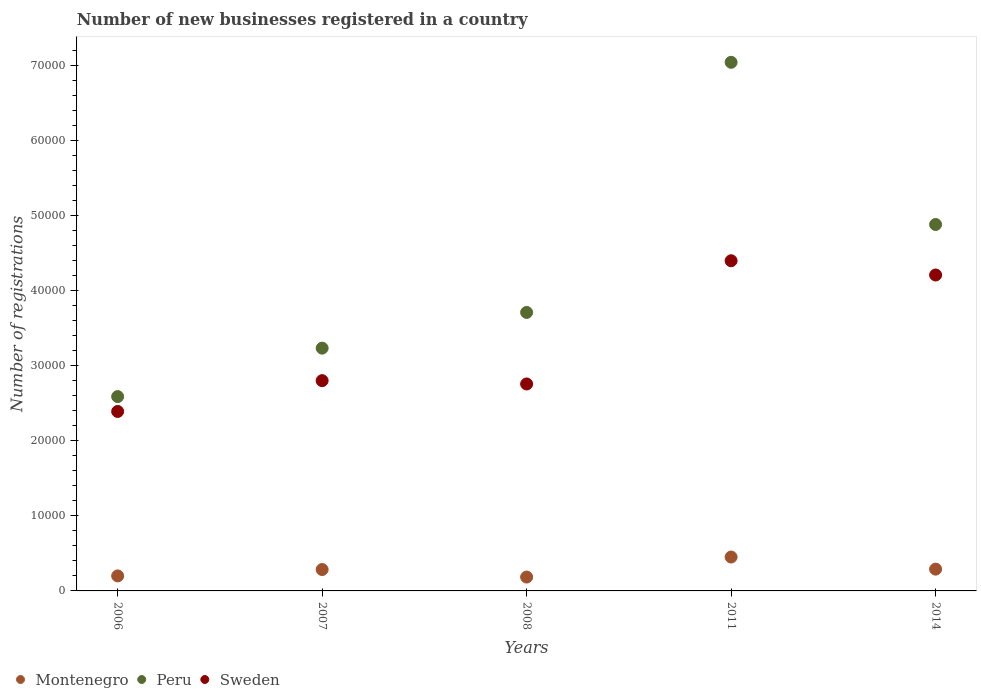What is the number of new businesses registered in Sweden in 2011?
Your response must be concise. 4.40e+04. Across all years, what is the maximum number of new businesses registered in Peru?
Offer a terse response. 7.04e+04. Across all years, what is the minimum number of new businesses registered in Peru?
Make the answer very short. 2.59e+04. In which year was the number of new businesses registered in Sweden maximum?
Keep it short and to the point. 2011. In which year was the number of new businesses registered in Peru minimum?
Your answer should be compact. 2006. What is the total number of new businesses registered in Sweden in the graph?
Your answer should be very brief. 1.65e+05. What is the difference between the number of new businesses registered in Montenegro in 2007 and that in 2011?
Offer a very short reply. -1665. What is the difference between the number of new businesses registered in Sweden in 2011 and the number of new businesses registered in Peru in 2007?
Your answer should be very brief. 1.16e+04. What is the average number of new businesses registered in Montenegro per year?
Keep it short and to the point. 2821.4. In the year 2007, what is the difference between the number of new businesses registered in Sweden and number of new businesses registered in Peru?
Your answer should be very brief. -4327. What is the ratio of the number of new businesses registered in Sweden in 2007 to that in 2014?
Keep it short and to the point. 0.67. Is the number of new businesses registered in Montenegro in 2008 less than that in 2011?
Give a very brief answer. Yes. Is the difference between the number of new businesses registered in Sweden in 2006 and 2011 greater than the difference between the number of new businesses registered in Peru in 2006 and 2011?
Provide a succinct answer. Yes. What is the difference between the highest and the second highest number of new businesses registered in Montenegro?
Your answer should be compact. 1612. What is the difference between the highest and the lowest number of new businesses registered in Sweden?
Your response must be concise. 2.01e+04. How many dotlines are there?
Give a very brief answer. 3. How many years are there in the graph?
Provide a succinct answer. 5. What is the difference between two consecutive major ticks on the Y-axis?
Provide a short and direct response. 10000. Are the values on the major ticks of Y-axis written in scientific E-notation?
Give a very brief answer. No. How many legend labels are there?
Offer a terse response. 3. What is the title of the graph?
Offer a terse response. Number of new businesses registered in a country. What is the label or title of the Y-axis?
Provide a short and direct response. Number of registrations. What is the Number of registrations of Montenegro in 2006?
Offer a terse response. 1999. What is the Number of registrations of Peru in 2006?
Give a very brief answer. 2.59e+04. What is the Number of registrations in Sweden in 2006?
Offer a very short reply. 2.39e+04. What is the Number of registrations of Montenegro in 2007?
Ensure brevity in your answer.  2848. What is the Number of registrations in Peru in 2007?
Provide a short and direct response. 3.23e+04. What is the Number of registrations in Sweden in 2007?
Your answer should be very brief. 2.80e+04. What is the Number of registrations of Montenegro in 2008?
Provide a short and direct response. 1846. What is the Number of registrations of Peru in 2008?
Make the answer very short. 3.71e+04. What is the Number of registrations in Sweden in 2008?
Give a very brief answer. 2.76e+04. What is the Number of registrations in Montenegro in 2011?
Offer a very short reply. 4513. What is the Number of registrations in Peru in 2011?
Provide a short and direct response. 7.04e+04. What is the Number of registrations in Sweden in 2011?
Ensure brevity in your answer.  4.40e+04. What is the Number of registrations in Montenegro in 2014?
Your answer should be compact. 2901. What is the Number of registrations of Peru in 2014?
Make the answer very short. 4.88e+04. What is the Number of registrations of Sweden in 2014?
Your answer should be very brief. 4.21e+04. Across all years, what is the maximum Number of registrations in Montenegro?
Keep it short and to the point. 4513. Across all years, what is the maximum Number of registrations of Peru?
Provide a succinct answer. 7.04e+04. Across all years, what is the maximum Number of registrations in Sweden?
Give a very brief answer. 4.40e+04. Across all years, what is the minimum Number of registrations of Montenegro?
Ensure brevity in your answer.  1846. Across all years, what is the minimum Number of registrations in Peru?
Provide a succinct answer. 2.59e+04. Across all years, what is the minimum Number of registrations of Sweden?
Offer a very short reply. 2.39e+04. What is the total Number of registrations in Montenegro in the graph?
Your answer should be very brief. 1.41e+04. What is the total Number of registrations in Peru in the graph?
Your answer should be very brief. 2.14e+05. What is the total Number of registrations in Sweden in the graph?
Provide a succinct answer. 1.65e+05. What is the difference between the Number of registrations in Montenegro in 2006 and that in 2007?
Provide a short and direct response. -849. What is the difference between the Number of registrations in Peru in 2006 and that in 2007?
Offer a very short reply. -6450. What is the difference between the Number of registrations in Sweden in 2006 and that in 2007?
Offer a very short reply. -4103. What is the difference between the Number of registrations in Montenegro in 2006 and that in 2008?
Your response must be concise. 153. What is the difference between the Number of registrations in Peru in 2006 and that in 2008?
Provide a short and direct response. -1.12e+04. What is the difference between the Number of registrations in Sweden in 2006 and that in 2008?
Your answer should be compact. -3661. What is the difference between the Number of registrations of Montenegro in 2006 and that in 2011?
Ensure brevity in your answer.  -2514. What is the difference between the Number of registrations of Peru in 2006 and that in 2011?
Offer a very short reply. -4.45e+04. What is the difference between the Number of registrations of Sweden in 2006 and that in 2011?
Keep it short and to the point. -2.01e+04. What is the difference between the Number of registrations in Montenegro in 2006 and that in 2014?
Your response must be concise. -902. What is the difference between the Number of registrations in Peru in 2006 and that in 2014?
Make the answer very short. -2.29e+04. What is the difference between the Number of registrations in Sweden in 2006 and that in 2014?
Your answer should be compact. -1.82e+04. What is the difference between the Number of registrations of Montenegro in 2007 and that in 2008?
Make the answer very short. 1002. What is the difference between the Number of registrations of Peru in 2007 and that in 2008?
Give a very brief answer. -4755. What is the difference between the Number of registrations in Sweden in 2007 and that in 2008?
Provide a succinct answer. 442. What is the difference between the Number of registrations of Montenegro in 2007 and that in 2011?
Give a very brief answer. -1665. What is the difference between the Number of registrations of Peru in 2007 and that in 2011?
Your response must be concise. -3.81e+04. What is the difference between the Number of registrations of Sweden in 2007 and that in 2011?
Keep it short and to the point. -1.60e+04. What is the difference between the Number of registrations of Montenegro in 2007 and that in 2014?
Offer a terse response. -53. What is the difference between the Number of registrations in Peru in 2007 and that in 2014?
Make the answer very short. -1.65e+04. What is the difference between the Number of registrations of Sweden in 2007 and that in 2014?
Offer a terse response. -1.41e+04. What is the difference between the Number of registrations in Montenegro in 2008 and that in 2011?
Your response must be concise. -2667. What is the difference between the Number of registrations of Peru in 2008 and that in 2011?
Provide a succinct answer. -3.33e+04. What is the difference between the Number of registrations of Sweden in 2008 and that in 2011?
Provide a short and direct response. -1.64e+04. What is the difference between the Number of registrations in Montenegro in 2008 and that in 2014?
Give a very brief answer. -1055. What is the difference between the Number of registrations in Peru in 2008 and that in 2014?
Offer a terse response. -1.17e+04. What is the difference between the Number of registrations of Sweden in 2008 and that in 2014?
Make the answer very short. -1.45e+04. What is the difference between the Number of registrations in Montenegro in 2011 and that in 2014?
Provide a short and direct response. 1612. What is the difference between the Number of registrations of Peru in 2011 and that in 2014?
Your answer should be very brief. 2.16e+04. What is the difference between the Number of registrations of Sweden in 2011 and that in 2014?
Offer a very short reply. 1896. What is the difference between the Number of registrations in Montenegro in 2006 and the Number of registrations in Peru in 2007?
Keep it short and to the point. -3.03e+04. What is the difference between the Number of registrations of Montenegro in 2006 and the Number of registrations of Sweden in 2007?
Ensure brevity in your answer.  -2.60e+04. What is the difference between the Number of registrations of Peru in 2006 and the Number of registrations of Sweden in 2007?
Give a very brief answer. -2123. What is the difference between the Number of registrations of Montenegro in 2006 and the Number of registrations of Peru in 2008?
Offer a terse response. -3.51e+04. What is the difference between the Number of registrations of Montenegro in 2006 and the Number of registrations of Sweden in 2008?
Offer a terse response. -2.56e+04. What is the difference between the Number of registrations in Peru in 2006 and the Number of registrations in Sweden in 2008?
Offer a very short reply. -1681. What is the difference between the Number of registrations in Montenegro in 2006 and the Number of registrations in Peru in 2011?
Offer a terse response. -6.84e+04. What is the difference between the Number of registrations of Montenegro in 2006 and the Number of registrations of Sweden in 2011?
Offer a terse response. -4.20e+04. What is the difference between the Number of registrations of Peru in 2006 and the Number of registrations of Sweden in 2011?
Make the answer very short. -1.81e+04. What is the difference between the Number of registrations of Montenegro in 2006 and the Number of registrations of Peru in 2014?
Your response must be concise. -4.68e+04. What is the difference between the Number of registrations of Montenegro in 2006 and the Number of registrations of Sweden in 2014?
Offer a terse response. -4.01e+04. What is the difference between the Number of registrations in Peru in 2006 and the Number of registrations in Sweden in 2014?
Your answer should be compact. -1.62e+04. What is the difference between the Number of registrations of Montenegro in 2007 and the Number of registrations of Peru in 2008?
Offer a terse response. -3.42e+04. What is the difference between the Number of registrations of Montenegro in 2007 and the Number of registrations of Sweden in 2008?
Make the answer very short. -2.47e+04. What is the difference between the Number of registrations in Peru in 2007 and the Number of registrations in Sweden in 2008?
Your answer should be very brief. 4769. What is the difference between the Number of registrations in Montenegro in 2007 and the Number of registrations in Peru in 2011?
Keep it short and to the point. -6.75e+04. What is the difference between the Number of registrations of Montenegro in 2007 and the Number of registrations of Sweden in 2011?
Make the answer very short. -4.11e+04. What is the difference between the Number of registrations in Peru in 2007 and the Number of registrations in Sweden in 2011?
Make the answer very short. -1.16e+04. What is the difference between the Number of registrations in Montenegro in 2007 and the Number of registrations in Peru in 2014?
Provide a short and direct response. -4.59e+04. What is the difference between the Number of registrations in Montenegro in 2007 and the Number of registrations in Sweden in 2014?
Keep it short and to the point. -3.92e+04. What is the difference between the Number of registrations in Peru in 2007 and the Number of registrations in Sweden in 2014?
Make the answer very short. -9739. What is the difference between the Number of registrations in Montenegro in 2008 and the Number of registrations in Peru in 2011?
Your response must be concise. -6.85e+04. What is the difference between the Number of registrations of Montenegro in 2008 and the Number of registrations of Sweden in 2011?
Provide a succinct answer. -4.21e+04. What is the difference between the Number of registrations of Peru in 2008 and the Number of registrations of Sweden in 2011?
Offer a terse response. -6880. What is the difference between the Number of registrations in Montenegro in 2008 and the Number of registrations in Peru in 2014?
Provide a short and direct response. -4.69e+04. What is the difference between the Number of registrations in Montenegro in 2008 and the Number of registrations in Sweden in 2014?
Your answer should be compact. -4.02e+04. What is the difference between the Number of registrations in Peru in 2008 and the Number of registrations in Sweden in 2014?
Provide a short and direct response. -4984. What is the difference between the Number of registrations in Montenegro in 2011 and the Number of registrations in Peru in 2014?
Your answer should be compact. -4.43e+04. What is the difference between the Number of registrations in Montenegro in 2011 and the Number of registrations in Sweden in 2014?
Your response must be concise. -3.76e+04. What is the difference between the Number of registrations of Peru in 2011 and the Number of registrations of Sweden in 2014?
Offer a terse response. 2.83e+04. What is the average Number of registrations in Montenegro per year?
Offer a terse response. 2821.4. What is the average Number of registrations of Peru per year?
Your answer should be very brief. 4.29e+04. What is the average Number of registrations of Sweden per year?
Keep it short and to the point. 3.31e+04. In the year 2006, what is the difference between the Number of registrations of Montenegro and Number of registrations of Peru?
Give a very brief answer. -2.39e+04. In the year 2006, what is the difference between the Number of registrations in Montenegro and Number of registrations in Sweden?
Your answer should be compact. -2.19e+04. In the year 2006, what is the difference between the Number of registrations in Peru and Number of registrations in Sweden?
Offer a terse response. 1980. In the year 2007, what is the difference between the Number of registrations of Montenegro and Number of registrations of Peru?
Offer a terse response. -2.95e+04. In the year 2007, what is the difference between the Number of registrations in Montenegro and Number of registrations in Sweden?
Offer a very short reply. -2.51e+04. In the year 2007, what is the difference between the Number of registrations in Peru and Number of registrations in Sweden?
Offer a terse response. 4327. In the year 2008, what is the difference between the Number of registrations in Montenegro and Number of registrations in Peru?
Provide a succinct answer. -3.52e+04. In the year 2008, what is the difference between the Number of registrations in Montenegro and Number of registrations in Sweden?
Make the answer very short. -2.57e+04. In the year 2008, what is the difference between the Number of registrations of Peru and Number of registrations of Sweden?
Keep it short and to the point. 9524. In the year 2011, what is the difference between the Number of registrations of Montenegro and Number of registrations of Peru?
Ensure brevity in your answer.  -6.59e+04. In the year 2011, what is the difference between the Number of registrations in Montenegro and Number of registrations in Sweden?
Your response must be concise. -3.94e+04. In the year 2011, what is the difference between the Number of registrations in Peru and Number of registrations in Sweden?
Offer a very short reply. 2.64e+04. In the year 2014, what is the difference between the Number of registrations in Montenegro and Number of registrations in Peru?
Offer a terse response. -4.59e+04. In the year 2014, what is the difference between the Number of registrations of Montenegro and Number of registrations of Sweden?
Provide a succinct answer. -3.92e+04. In the year 2014, what is the difference between the Number of registrations of Peru and Number of registrations of Sweden?
Ensure brevity in your answer.  6724. What is the ratio of the Number of registrations in Montenegro in 2006 to that in 2007?
Ensure brevity in your answer.  0.7. What is the ratio of the Number of registrations in Peru in 2006 to that in 2007?
Give a very brief answer. 0.8. What is the ratio of the Number of registrations of Sweden in 2006 to that in 2007?
Ensure brevity in your answer.  0.85. What is the ratio of the Number of registrations in Montenegro in 2006 to that in 2008?
Offer a very short reply. 1.08. What is the ratio of the Number of registrations in Peru in 2006 to that in 2008?
Your response must be concise. 0.7. What is the ratio of the Number of registrations in Sweden in 2006 to that in 2008?
Your answer should be very brief. 0.87. What is the ratio of the Number of registrations in Montenegro in 2006 to that in 2011?
Your response must be concise. 0.44. What is the ratio of the Number of registrations in Peru in 2006 to that in 2011?
Make the answer very short. 0.37. What is the ratio of the Number of registrations of Sweden in 2006 to that in 2011?
Your answer should be very brief. 0.54. What is the ratio of the Number of registrations in Montenegro in 2006 to that in 2014?
Give a very brief answer. 0.69. What is the ratio of the Number of registrations of Peru in 2006 to that in 2014?
Keep it short and to the point. 0.53. What is the ratio of the Number of registrations of Sweden in 2006 to that in 2014?
Your response must be concise. 0.57. What is the ratio of the Number of registrations in Montenegro in 2007 to that in 2008?
Offer a terse response. 1.54. What is the ratio of the Number of registrations in Peru in 2007 to that in 2008?
Make the answer very short. 0.87. What is the ratio of the Number of registrations in Montenegro in 2007 to that in 2011?
Ensure brevity in your answer.  0.63. What is the ratio of the Number of registrations in Peru in 2007 to that in 2011?
Ensure brevity in your answer.  0.46. What is the ratio of the Number of registrations in Sweden in 2007 to that in 2011?
Ensure brevity in your answer.  0.64. What is the ratio of the Number of registrations of Montenegro in 2007 to that in 2014?
Provide a short and direct response. 0.98. What is the ratio of the Number of registrations in Peru in 2007 to that in 2014?
Your answer should be compact. 0.66. What is the ratio of the Number of registrations of Sweden in 2007 to that in 2014?
Offer a very short reply. 0.67. What is the ratio of the Number of registrations of Montenegro in 2008 to that in 2011?
Offer a very short reply. 0.41. What is the ratio of the Number of registrations of Peru in 2008 to that in 2011?
Ensure brevity in your answer.  0.53. What is the ratio of the Number of registrations in Sweden in 2008 to that in 2011?
Offer a very short reply. 0.63. What is the ratio of the Number of registrations in Montenegro in 2008 to that in 2014?
Provide a short and direct response. 0.64. What is the ratio of the Number of registrations of Peru in 2008 to that in 2014?
Give a very brief answer. 0.76. What is the ratio of the Number of registrations of Sweden in 2008 to that in 2014?
Ensure brevity in your answer.  0.66. What is the ratio of the Number of registrations of Montenegro in 2011 to that in 2014?
Ensure brevity in your answer.  1.56. What is the ratio of the Number of registrations in Peru in 2011 to that in 2014?
Your answer should be compact. 1.44. What is the ratio of the Number of registrations in Sweden in 2011 to that in 2014?
Your answer should be very brief. 1.05. What is the difference between the highest and the second highest Number of registrations in Montenegro?
Your answer should be compact. 1612. What is the difference between the highest and the second highest Number of registrations in Peru?
Offer a very short reply. 2.16e+04. What is the difference between the highest and the second highest Number of registrations in Sweden?
Give a very brief answer. 1896. What is the difference between the highest and the lowest Number of registrations of Montenegro?
Keep it short and to the point. 2667. What is the difference between the highest and the lowest Number of registrations in Peru?
Ensure brevity in your answer.  4.45e+04. What is the difference between the highest and the lowest Number of registrations in Sweden?
Keep it short and to the point. 2.01e+04. 